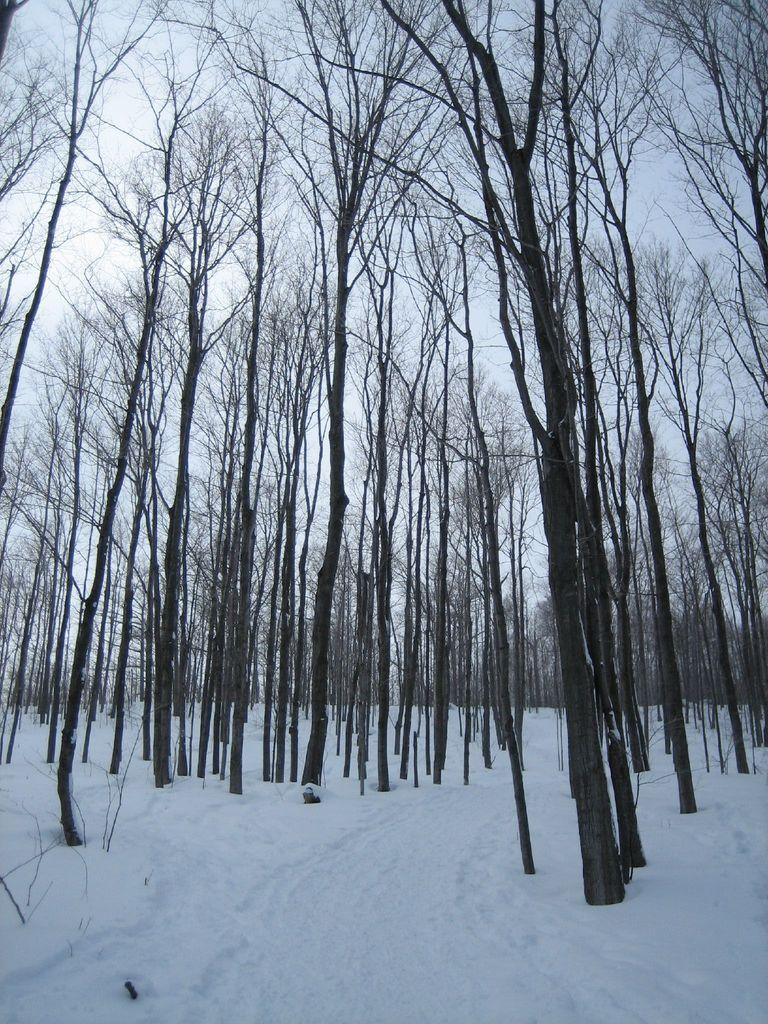What type of vegetation can be seen in the image? There are trees in the image. What is covering the ground in the image? There is snow at the bottom of the image. What part of the natural environment is visible in the image? The sky is visible in the background of the image. Can you see any flames coming from the trees in the image? There are no flames present in the image; it features trees with snow at the bottom. What type of relation can be seen between the trees and the snow in the image? The image does not depict a relation between the trees and the snow; it simply shows trees with snow at the bottom. 